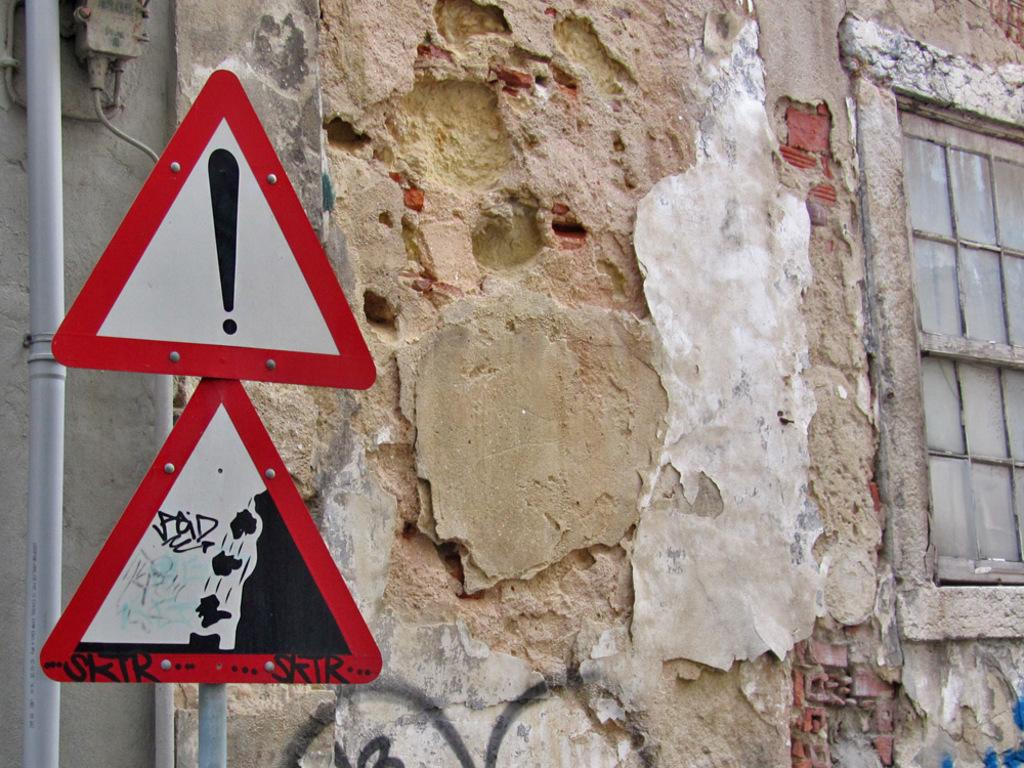What is attached to the pole in the image? There are sign boards attached to the pole in the image. What type of object can be seen in the image? There is a pipe in the image. What is the purpose of the object in the image? The purpose of the pipe is not clear from the provided facts. What type of structure is visible in the image? There is a wall in the image. What feature allows for natural light to enter the space in the image? There is a window in the image that allows natural light to enter. What type of card is being used to hold the pipe in place in the image? There is no card present in the image, and the pipe is not being held in place by any visible object. What type of plate is being used to cover the window in the image? There is no plate present in the image, and the window is not being covered by any visible object. 